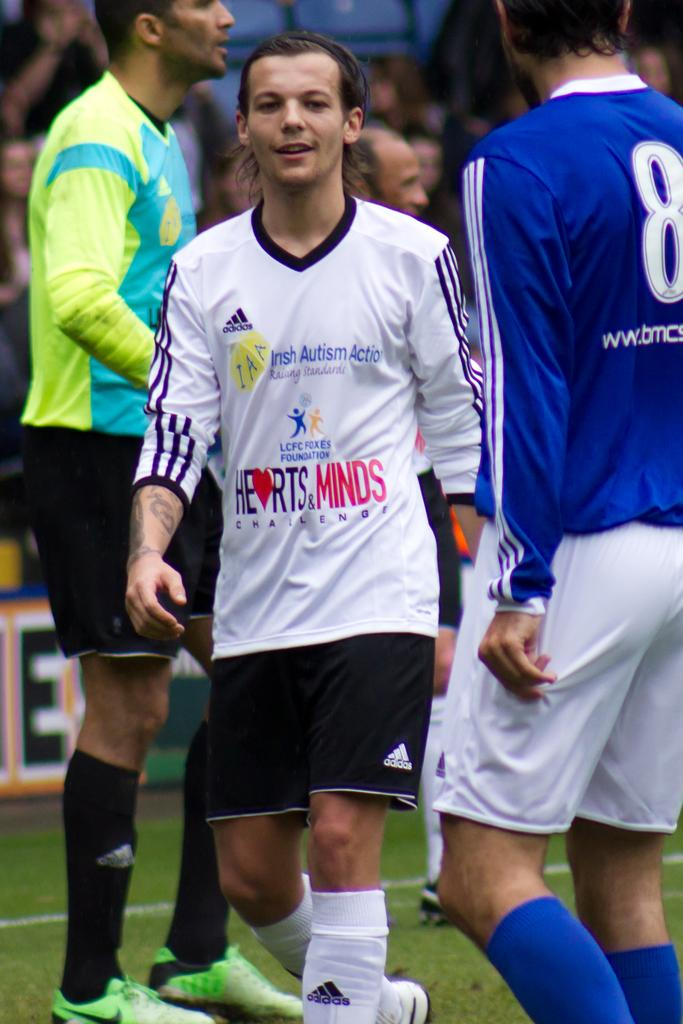<image>
Write a terse but informative summary of the picture. A man wearing a jersey that says Hearts and Minds. 